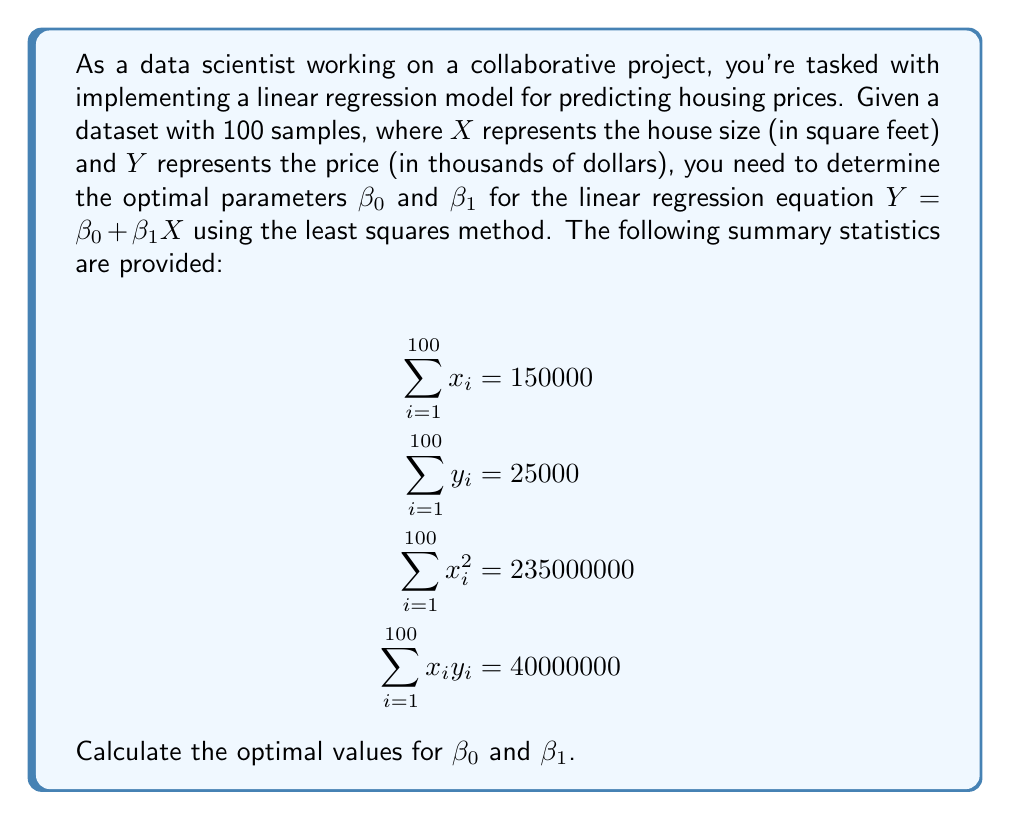Could you help me with this problem? To determine the optimal parameters $\beta_0$ and $\beta_1$ using the least squares method, we'll follow these steps:

1. Recall the formulas for $\beta_1$ and $\beta_0$:

   $$\beta_1 = \frac{n\sum x_iy_i - \sum x_i \sum y_i}{n\sum x_i^2 - (\sum x_i)^2}$$
   
   $$\beta_0 = \bar{y} - \beta_1\bar{x}$$

   where $n$ is the number of samples, and $\bar{x}$ and $\bar{y}$ are the means of $x$ and $y$ respectively.

2. Calculate $\bar{x}$ and $\bar{y}$:
   
   $$\bar{x} = \frac{\sum x_i}{n} = \frac{150000}{100} = 1500$$
   
   $$\bar{y} = \frac{\sum y_i}{n} = \frac{25000}{100} = 250$$

3. Calculate $\beta_1$:

   $$\beta_1 = \frac{100 \cdot 40000000 - 150000 \cdot 25000}{100 \cdot 235000000 - 150000^2}$$
   
   $$= \frac{4000000000 - 3750000000}{23500000000 - 22500000000}$$
   
   $$= \frac{250000000}{1000000000} = 0.25$$

4. Calculate $\beta_0$:

   $$\beta_0 = 250 - 0.25 \cdot 1500 = 250 - 375 = -125$$

Therefore, the optimal parameters for the linear regression model are $\beta_1 = 0.25$ and $\beta_0 = -125$.
Answer: $\beta_1 = 0.25$, $\beta_0 = -125$ 